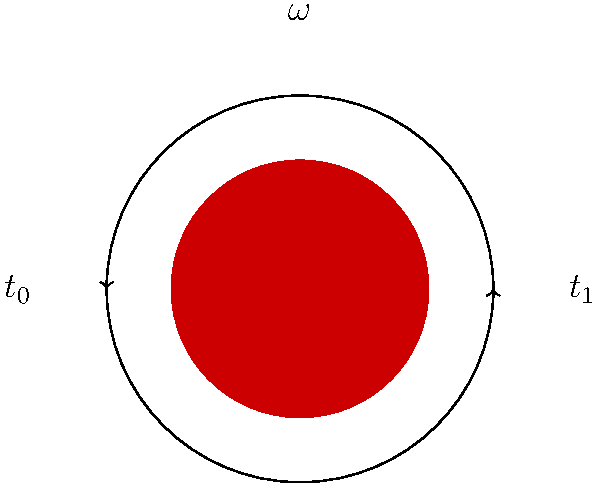In an analysis of early cricket ball spin techniques, a ball is observed to complete 3 full rotations between time $t_0$ and $t_1$, which are separated by 0.5 seconds. What is the angular velocity ($\omega$) of the ball in radians per second? To find the angular velocity of the cricket ball, we need to follow these steps:

1. Recognize that angular velocity ($\omega$) is defined as the rate of change of angular displacement with respect to time.

2. Calculate the total angular displacement:
   - One full rotation = $2\pi$ radians
   - 3 full rotations = $3 \times 2\pi = 6\pi$ radians

3. Identify the time interval:
   $\Delta t = t_1 - t_0 = 0.5$ seconds

4. Apply the formula for angular velocity:
   $$\omega = \frac{\text{angular displacement}}{\text{time interval}} = \frac{6\pi \text{ radians}}{0.5 \text{ seconds}}$$

5. Simplify the calculation:
   $$\omega = \frac{6\pi}{0.5} = 12\pi \text{ radians/second}$$

Therefore, the angular velocity of the early cricket ball is $12\pi$ radians per second.
Answer: $12\pi$ rad/s 